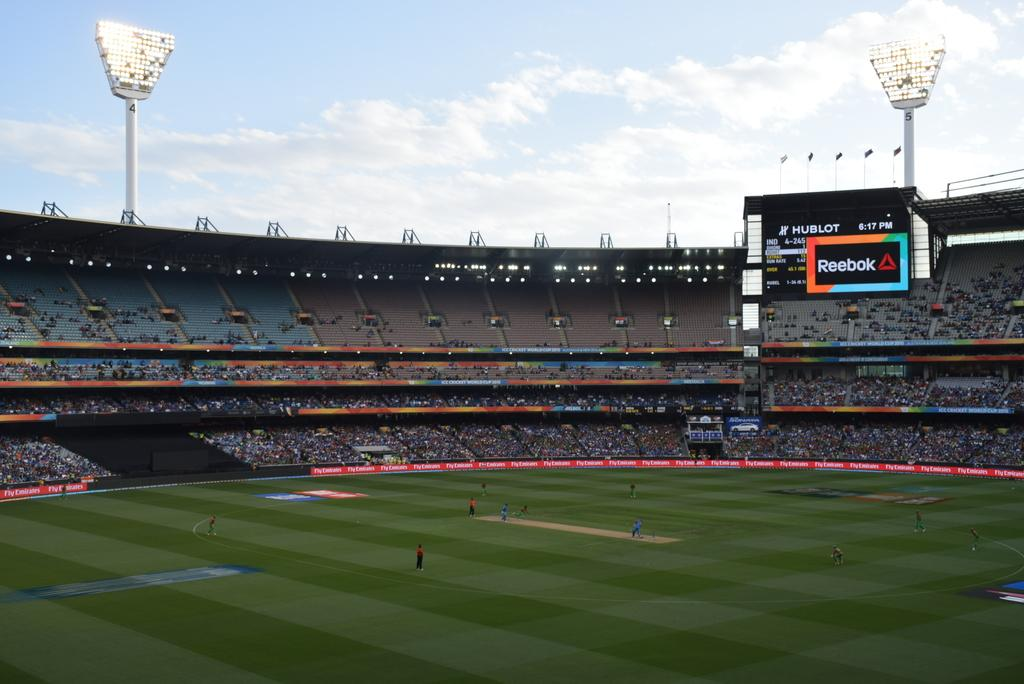<image>
Render a clear and concise summary of the photo. A crowded stadium with several people on the field at 6:17 PM. 